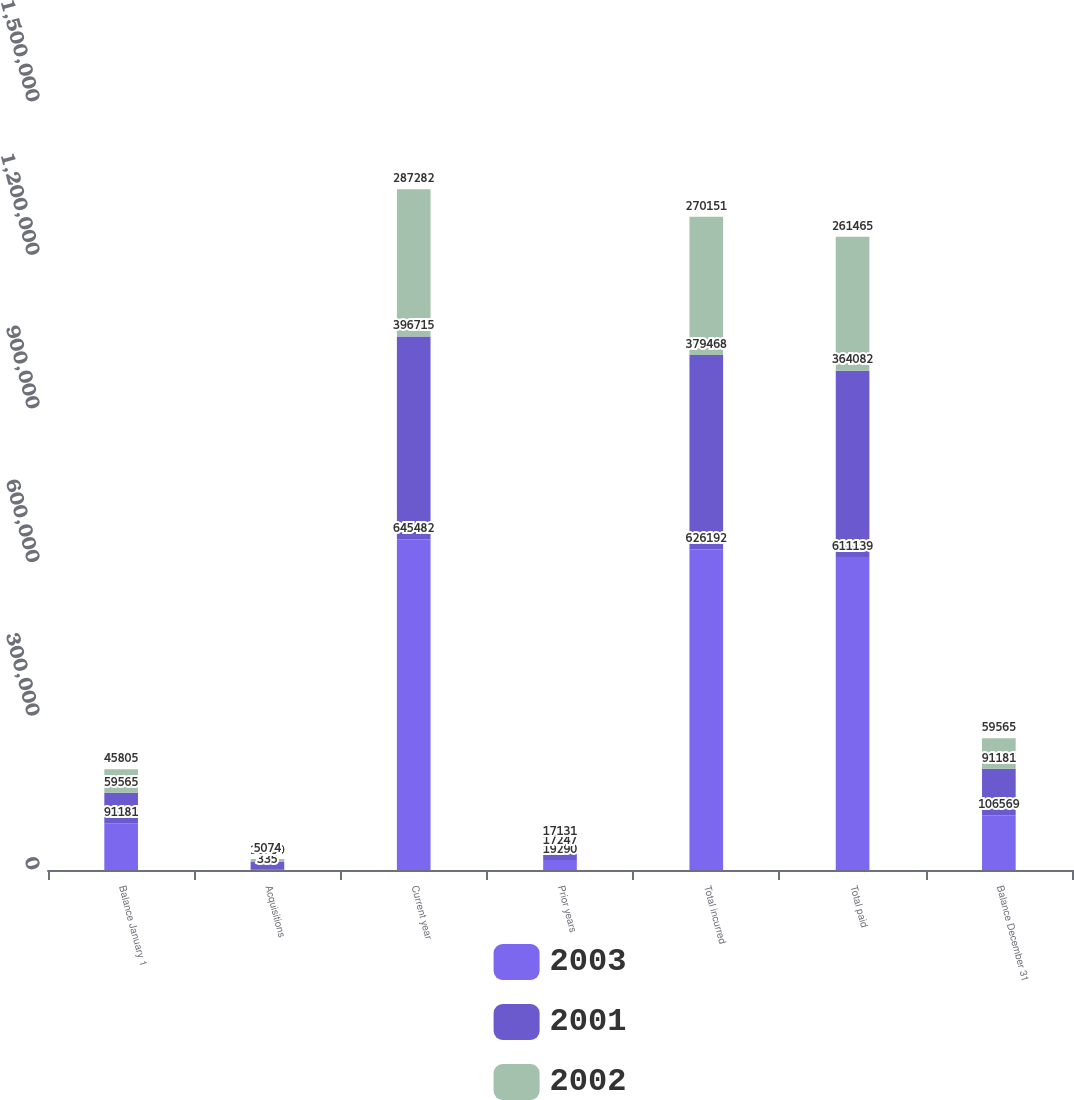Convert chart to OTSL. <chart><loc_0><loc_0><loc_500><loc_500><stacked_bar_chart><ecel><fcel>Balance January 1<fcel>Acquisitions<fcel>Current year<fcel>Prior years<fcel>Total incurred<fcel>Total paid<fcel>Balance December 31<nl><fcel>2003<fcel>91181<fcel>335<fcel>645482<fcel>19290<fcel>626192<fcel>611139<fcel>106569<nl><fcel>2001<fcel>59565<fcel>16230<fcel>396715<fcel>17247<fcel>379468<fcel>364082<fcel>91181<nl><fcel>2002<fcel>45805<fcel>5074<fcel>287282<fcel>17131<fcel>270151<fcel>261465<fcel>59565<nl></chart> 